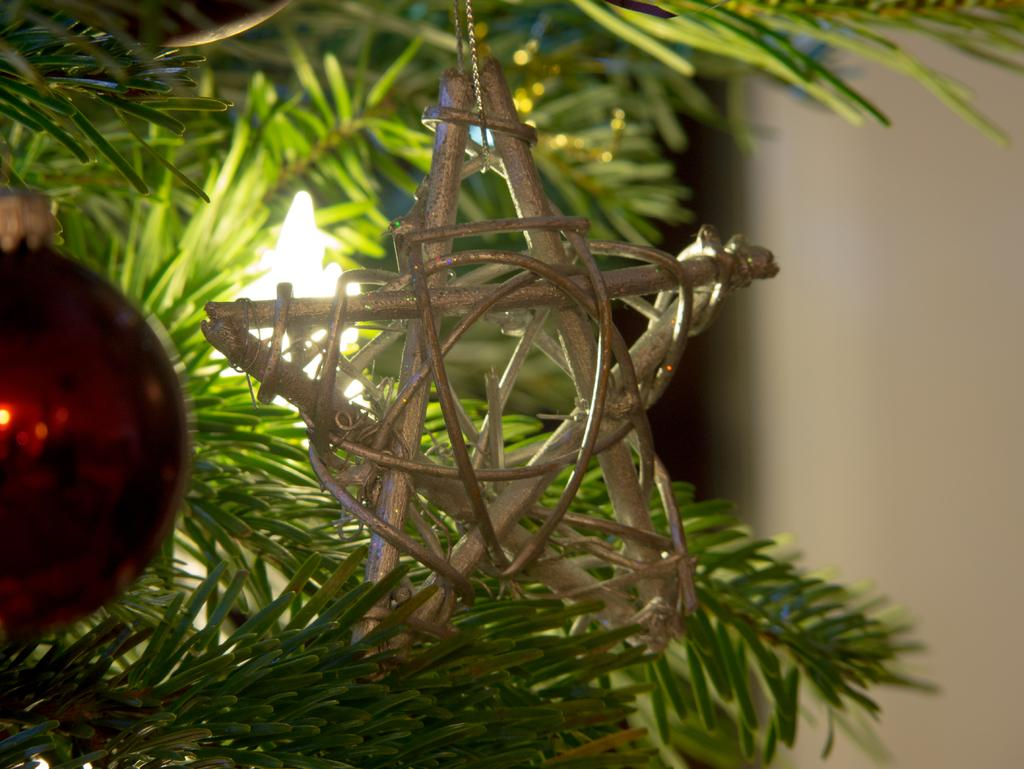What is the main subject in the foreground of the picture? There is a star in the foreground of the picture. What else can be seen in the foreground of the picture? There is a red ball hanging from a tree in the foreground. What is visible in the background of the picture? There is a light and a wall in the background of the picture. What type of fuel is being used by the star in the image? There is no indication in the image that the star requires fuel, as stars are celestial bodies that emit light through nuclear fusion. 